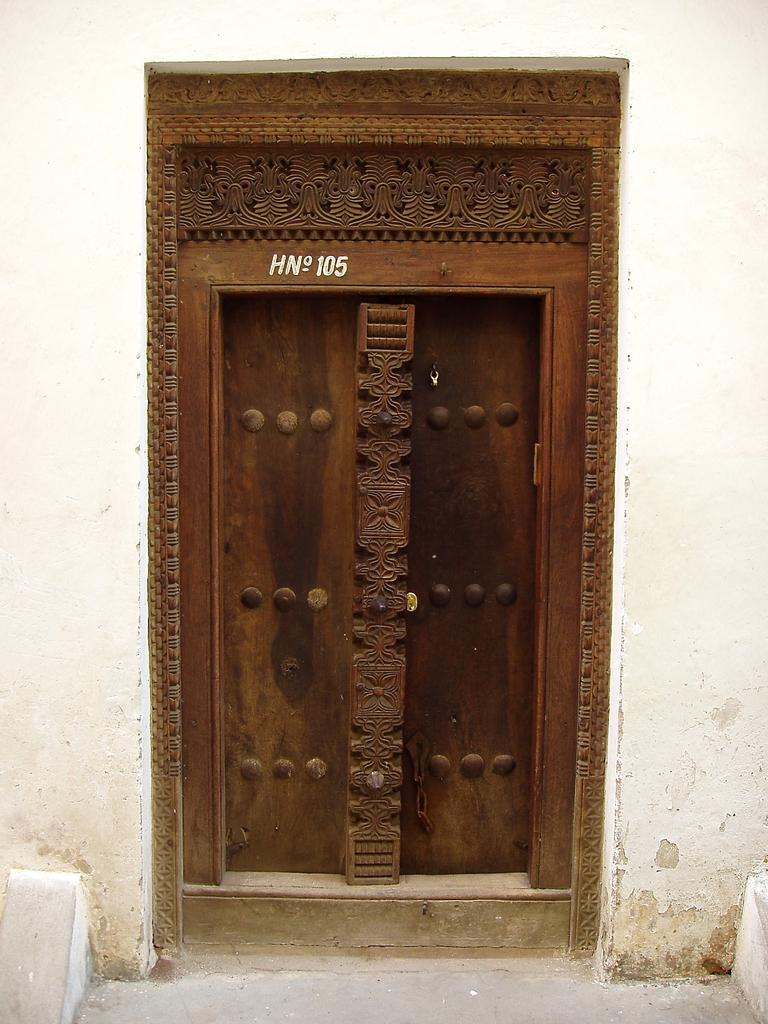What is the main subject of the image? The main subject of the image is the main door of a building. What information is displayed on the main door? The house number is present on the main door. What type of can is visible on the door in the image? There is no can present on the door in the image. What kind of mountain can be seen in the background of the image? There is no mountain visible in the image; it only shows the main door of a building. 